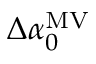<formula> <loc_0><loc_0><loc_500><loc_500>\Delta \alpha _ { 0 } ^ { M V }</formula> 